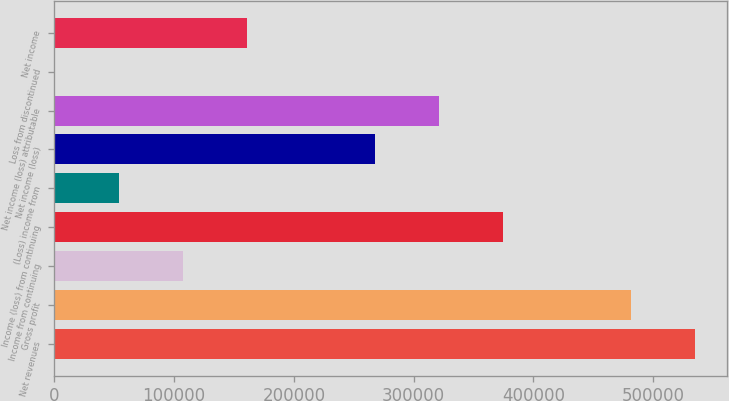Convert chart to OTSL. <chart><loc_0><loc_0><loc_500><loc_500><bar_chart><fcel>Net revenues<fcel>Gross profit<fcel>Income from continuing<fcel>Income (loss) from continuing<fcel>(Loss) income from<fcel>Net income (loss)<fcel>Net income (loss) attributable<fcel>Loss from discontinued<fcel>Net income<nl><fcel>534703<fcel>481245<fcel>107038<fcel>374329<fcel>53580.1<fcel>267412<fcel>320871<fcel>122<fcel>160496<nl></chart> 